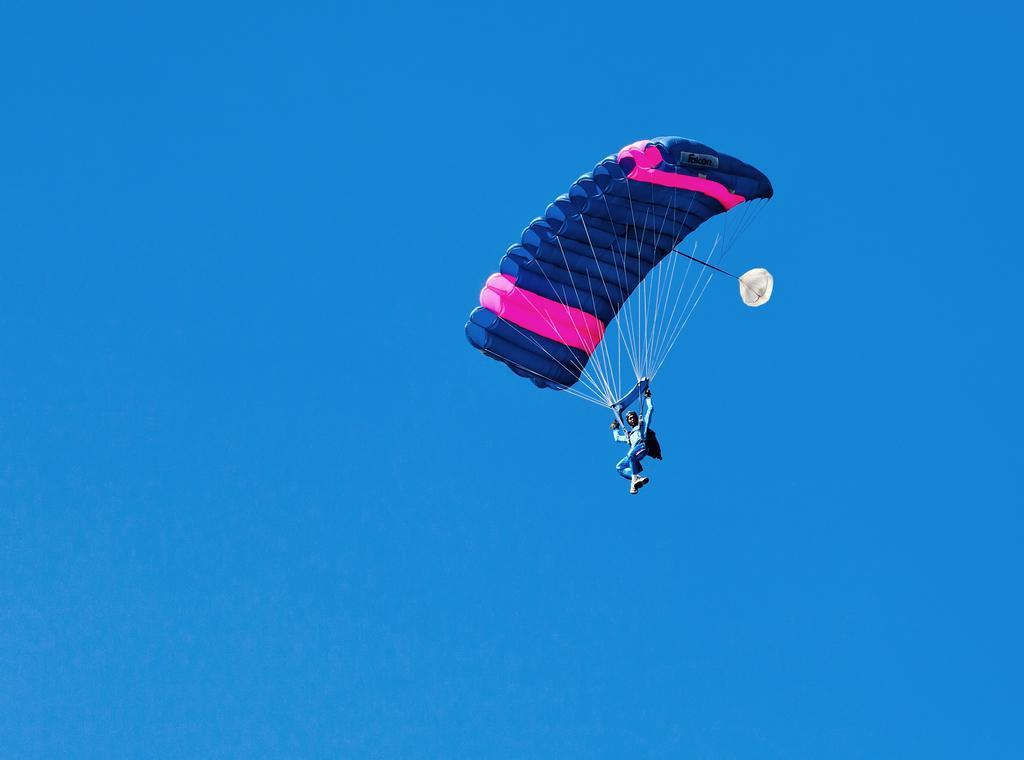What activity is the person in the image engaged in? The person is paragliding in the image. Where is the person located in the image? The person is in the air. What can be seen in the background of the image? There is sky visible in the background of the image. What type of shoe is the robin wearing in the image? There is no robin or shoe present in the image; it features a person paragliding in the air. 